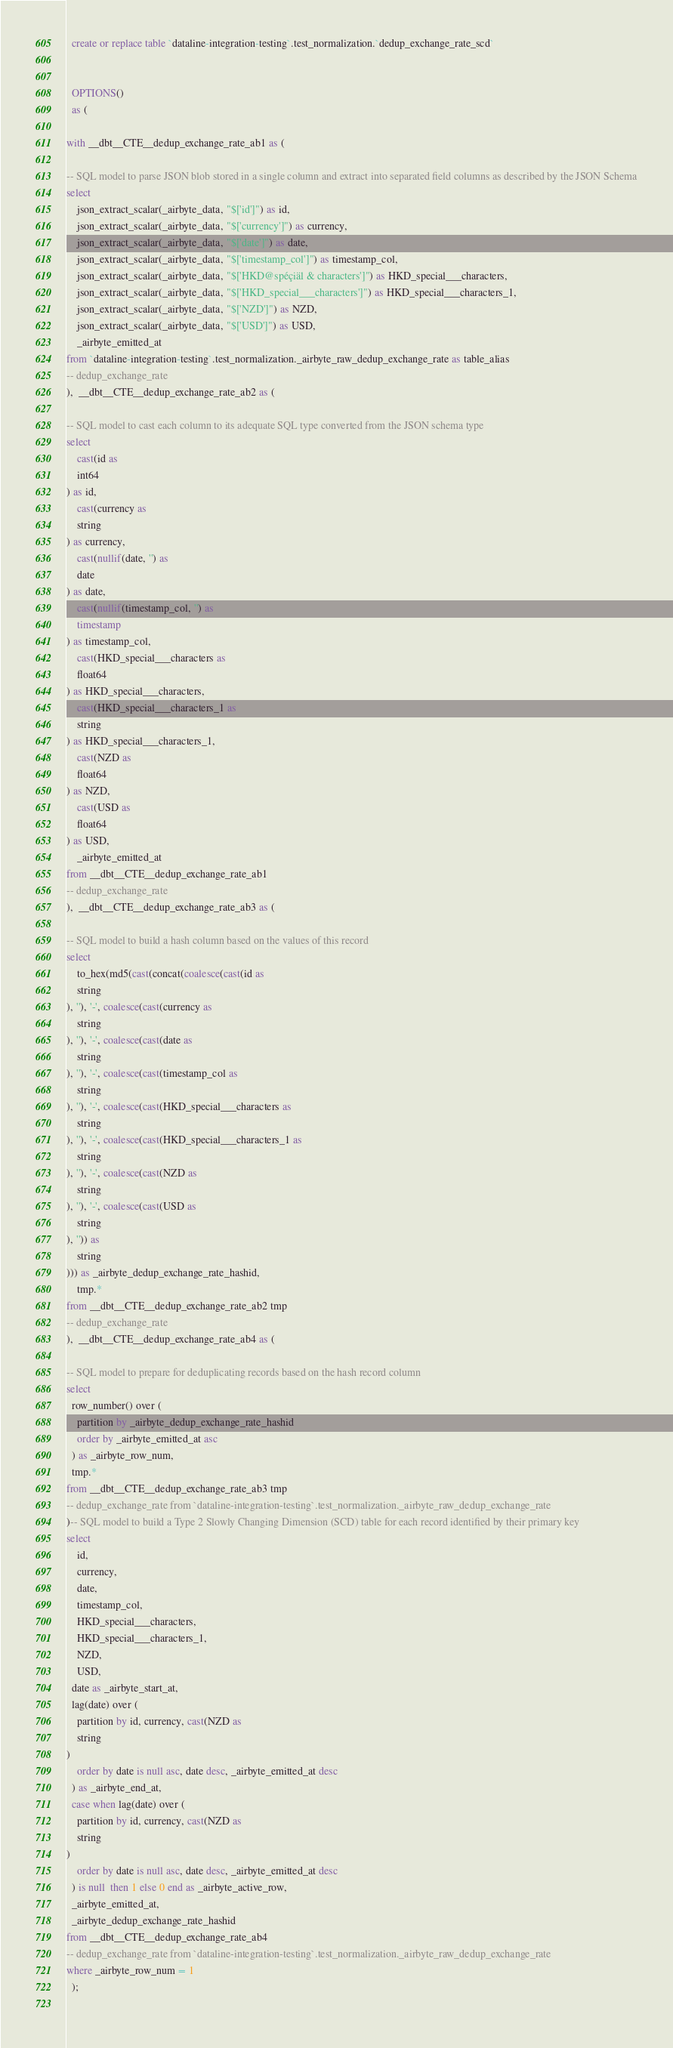<code> <loc_0><loc_0><loc_500><loc_500><_SQL_>

  create or replace table `dataline-integration-testing`.test_normalization.`dedup_exchange_rate_scd`
  
  
  OPTIONS()
  as (
    
with __dbt__CTE__dedup_exchange_rate_ab1 as (

-- SQL model to parse JSON blob stored in a single column and extract into separated field columns as described by the JSON Schema
select
    json_extract_scalar(_airbyte_data, "$['id']") as id,
    json_extract_scalar(_airbyte_data, "$['currency']") as currency,
    json_extract_scalar(_airbyte_data, "$['date']") as date,
    json_extract_scalar(_airbyte_data, "$['timestamp_col']") as timestamp_col,
    json_extract_scalar(_airbyte_data, "$['HKD@spéçiäl & characters']") as HKD_special___characters,
    json_extract_scalar(_airbyte_data, "$['HKD_special___characters']") as HKD_special___characters_1,
    json_extract_scalar(_airbyte_data, "$['NZD']") as NZD,
    json_extract_scalar(_airbyte_data, "$['USD']") as USD,
    _airbyte_emitted_at
from `dataline-integration-testing`.test_normalization._airbyte_raw_dedup_exchange_rate as table_alias
-- dedup_exchange_rate
),  __dbt__CTE__dedup_exchange_rate_ab2 as (

-- SQL model to cast each column to its adequate SQL type converted from the JSON schema type
select
    cast(id as 
    int64
) as id,
    cast(currency as 
    string
) as currency,
    cast(nullif(date, '') as
    date
) as date,
    cast(nullif(timestamp_col, '') as
    timestamp
) as timestamp_col,
    cast(HKD_special___characters as 
    float64
) as HKD_special___characters,
    cast(HKD_special___characters_1 as 
    string
) as HKD_special___characters_1,
    cast(NZD as 
    float64
) as NZD,
    cast(USD as 
    float64
) as USD,
    _airbyte_emitted_at
from __dbt__CTE__dedup_exchange_rate_ab1
-- dedup_exchange_rate
),  __dbt__CTE__dedup_exchange_rate_ab3 as (

-- SQL model to build a hash column based on the values of this record
select
    to_hex(md5(cast(concat(coalesce(cast(id as 
    string
), ''), '-', coalesce(cast(currency as 
    string
), ''), '-', coalesce(cast(date as 
    string
), ''), '-', coalesce(cast(timestamp_col as 
    string
), ''), '-', coalesce(cast(HKD_special___characters as 
    string
), ''), '-', coalesce(cast(HKD_special___characters_1 as 
    string
), ''), '-', coalesce(cast(NZD as 
    string
), ''), '-', coalesce(cast(USD as 
    string
), '')) as 
    string
))) as _airbyte_dedup_exchange_rate_hashid,
    tmp.*
from __dbt__CTE__dedup_exchange_rate_ab2 tmp
-- dedup_exchange_rate
),  __dbt__CTE__dedup_exchange_rate_ab4 as (

-- SQL model to prepare for deduplicating records based on the hash record column
select
  row_number() over (
    partition by _airbyte_dedup_exchange_rate_hashid
    order by _airbyte_emitted_at asc
  ) as _airbyte_row_num,
  tmp.*
from __dbt__CTE__dedup_exchange_rate_ab3 tmp
-- dedup_exchange_rate from `dataline-integration-testing`.test_normalization._airbyte_raw_dedup_exchange_rate
)-- SQL model to build a Type 2 Slowly Changing Dimension (SCD) table for each record identified by their primary key
select
    id,
    currency,
    date,
    timestamp_col,
    HKD_special___characters,
    HKD_special___characters_1,
    NZD,
    USD,
  date as _airbyte_start_at,
  lag(date) over (
    partition by id, currency, cast(NZD as 
    string
)
    order by date is null asc, date desc, _airbyte_emitted_at desc
  ) as _airbyte_end_at,
  case when lag(date) over (
    partition by id, currency, cast(NZD as 
    string
)
    order by date is null asc, date desc, _airbyte_emitted_at desc
  ) is null  then 1 else 0 end as _airbyte_active_row,
  _airbyte_emitted_at,
  _airbyte_dedup_exchange_rate_hashid
from __dbt__CTE__dedup_exchange_rate_ab4
-- dedup_exchange_rate from `dataline-integration-testing`.test_normalization._airbyte_raw_dedup_exchange_rate
where _airbyte_row_num = 1
  );
    </code> 